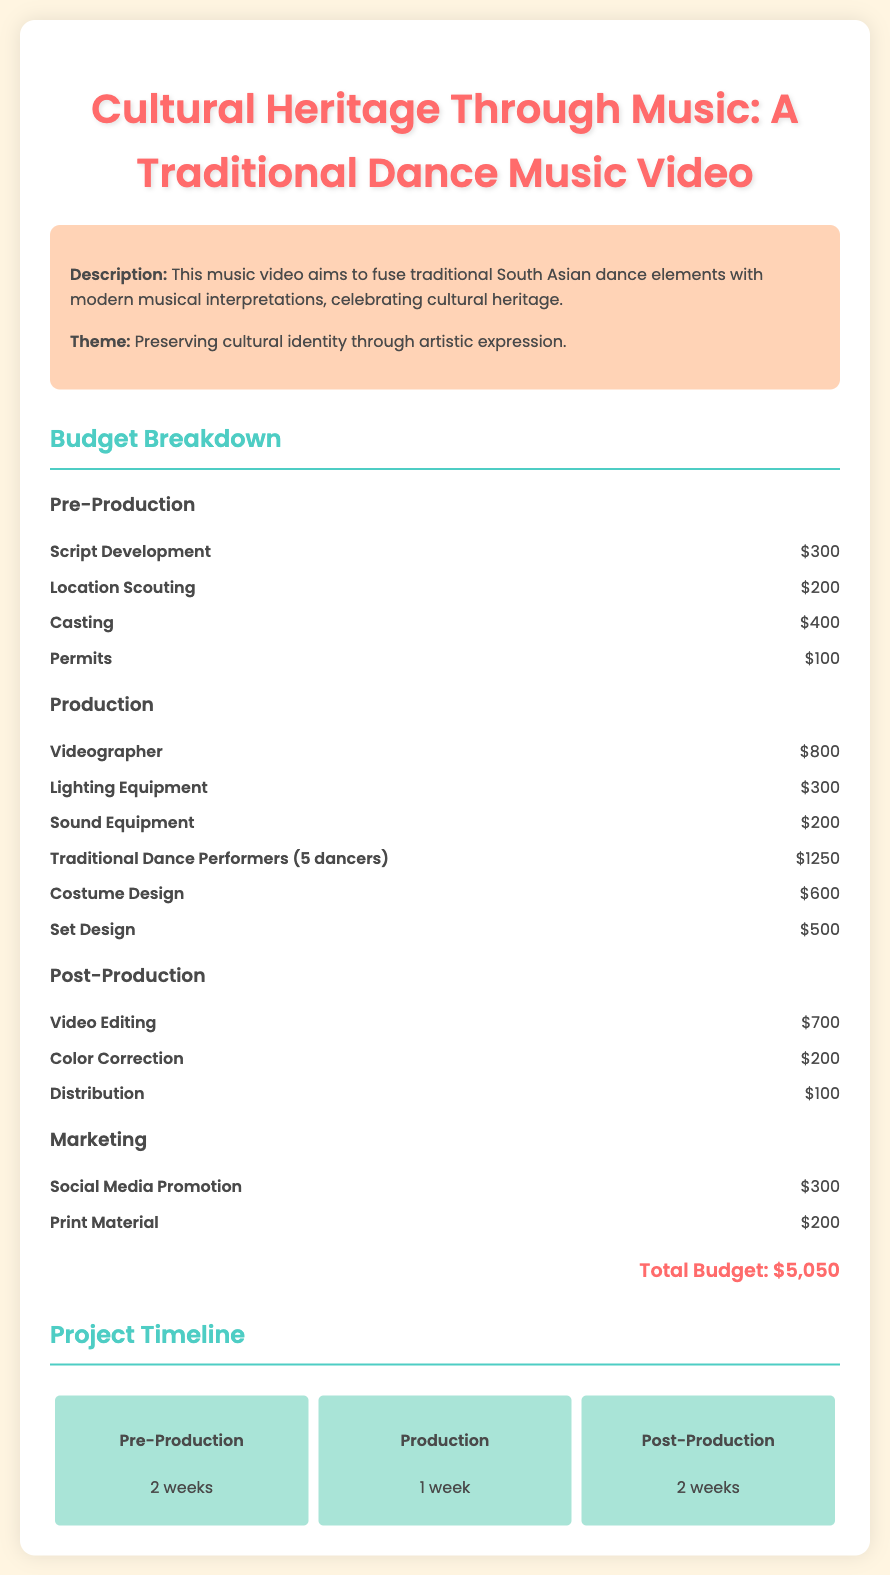what is the total budget? The total budget is clearly mentioned at the bottom of the budget section.
Answer: $5,050 how many dancers are included in the video? The document specifies the number of traditional dance performers required for the production.
Answer: 5 dancers what is the cost for costume design? The budget item for costume design is listed with its associated cost.
Answer: $600 how long is the production phase? The timeline outlines the duration of the production phase.
Answer: 1 week what is the total cost for video editing and color correction combined? The cost for video editing and color correction needs to be summed based on the budget breakdown.
Answer: $900 what is the main theme of the music video? The theme of the project is provided in the overview section.
Answer: Preserving cultural identity through artistic expression which section has the highest budget allocation? By examining each section's budget items, we can see which section's total is the greatest.
Answer: Production how long will the post-production take? The document specifies the duration allocated for post-production in the project timeline.
Answer: 2 weeks what are the two categories listed under Marketing? The marketing section consists of specific budget items, which can be directly referenced.
Answer: Social Media Promotion, Print Material 